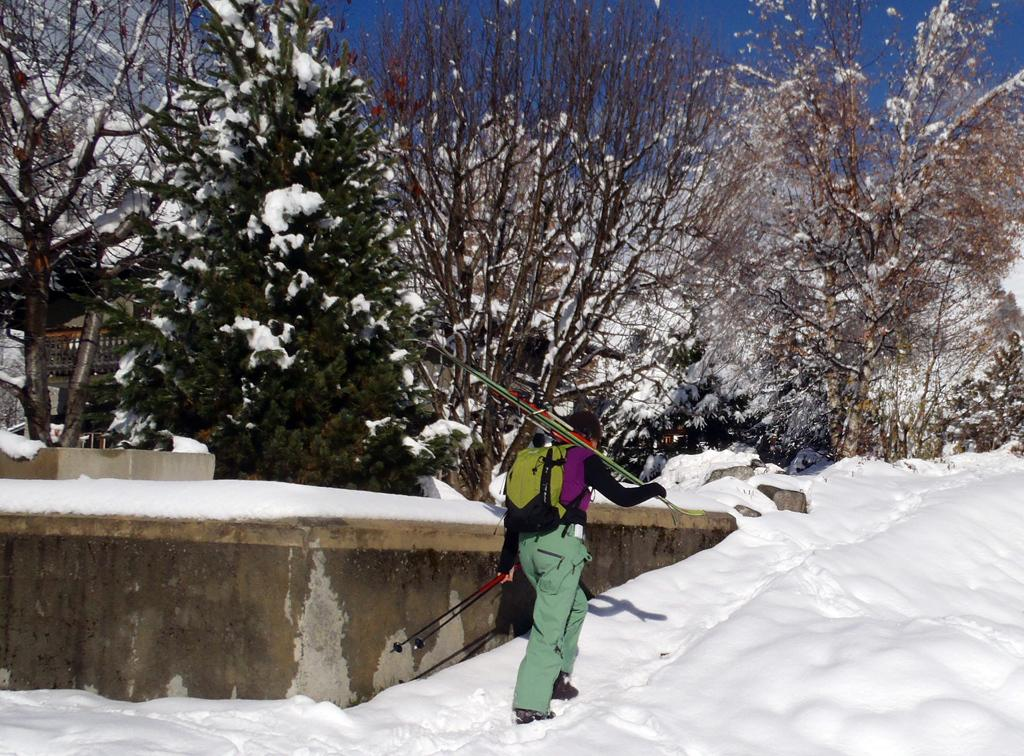What is the main feature of the landscape in the image? There are many trees in the image. What can be seen in the background of the image? The sky is visible in the image. What is the person in the image doing? A person is walking in the image. What is the person carrying while walking? The person is carrying objects. What is the weather like in the image? There is snow in the image, indicating a cold or wintry weather. What time of day is it in the image, based on the agreement between the trees and the sky? There is no mention of an agreement between the trees and the sky in the image, and therefore we cannot determine the time of day based on that. 